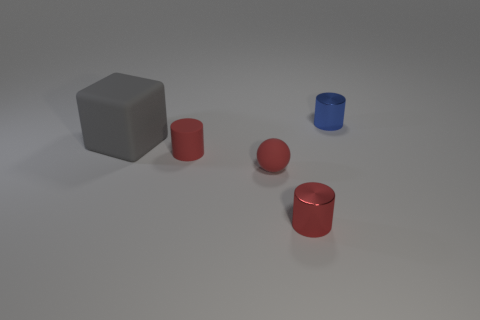Subtract all red metallic cylinders. How many cylinders are left? 2 Subtract all yellow spheres. How many red cylinders are left? 2 Add 1 large things. How many objects exist? 6 Subtract all blocks. How many objects are left? 4 Add 2 big gray cubes. How many big gray cubes exist? 3 Subtract 0 purple spheres. How many objects are left? 5 Subtract all small red balls. Subtract all blue cylinders. How many objects are left? 3 Add 4 big blocks. How many big blocks are left? 5 